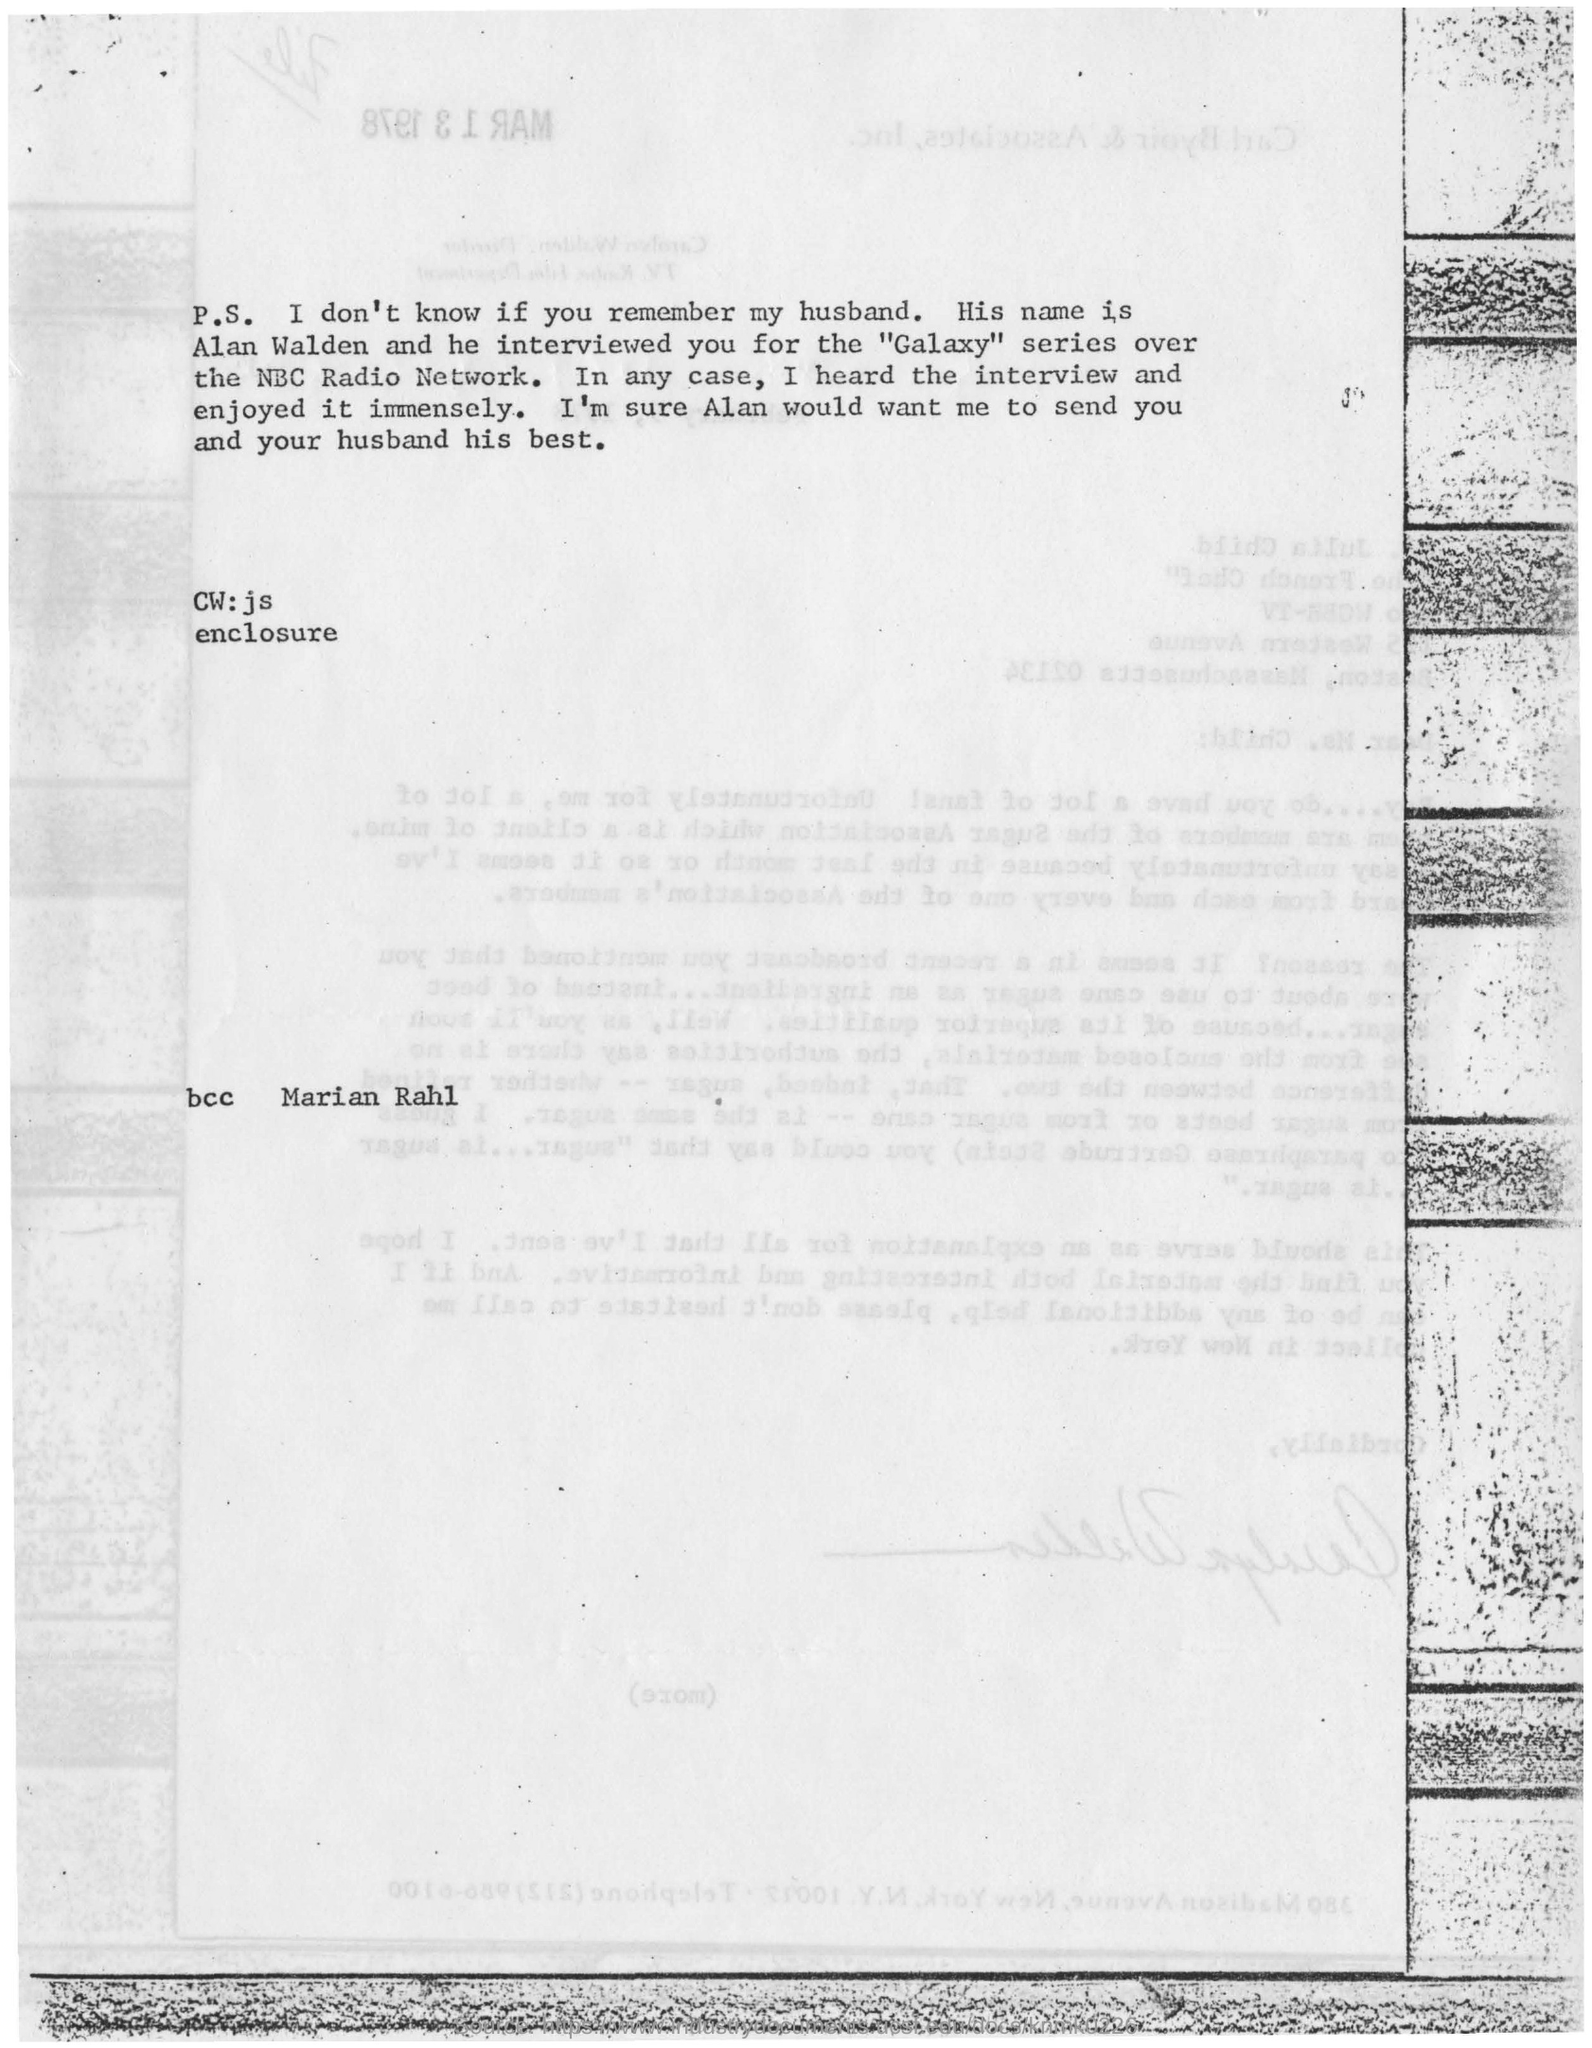Give some essential details in this illustration. The person mentioned in the "BCC" field is Marian Rahl. 